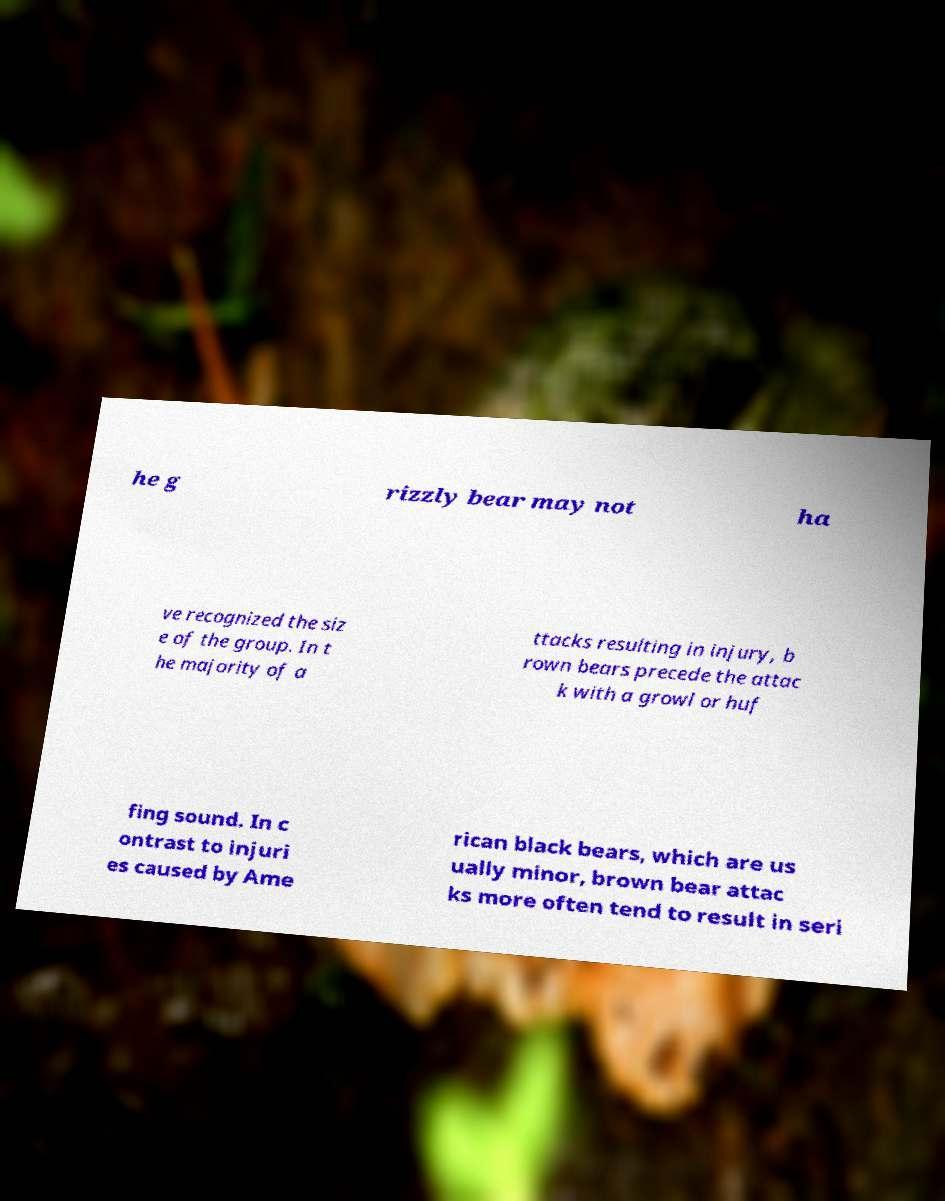I need the written content from this picture converted into text. Can you do that? he g rizzly bear may not ha ve recognized the siz e of the group. In t he majority of a ttacks resulting in injury, b rown bears precede the attac k with a growl or huf fing sound. In c ontrast to injuri es caused by Ame rican black bears, which are us ually minor, brown bear attac ks more often tend to result in seri 